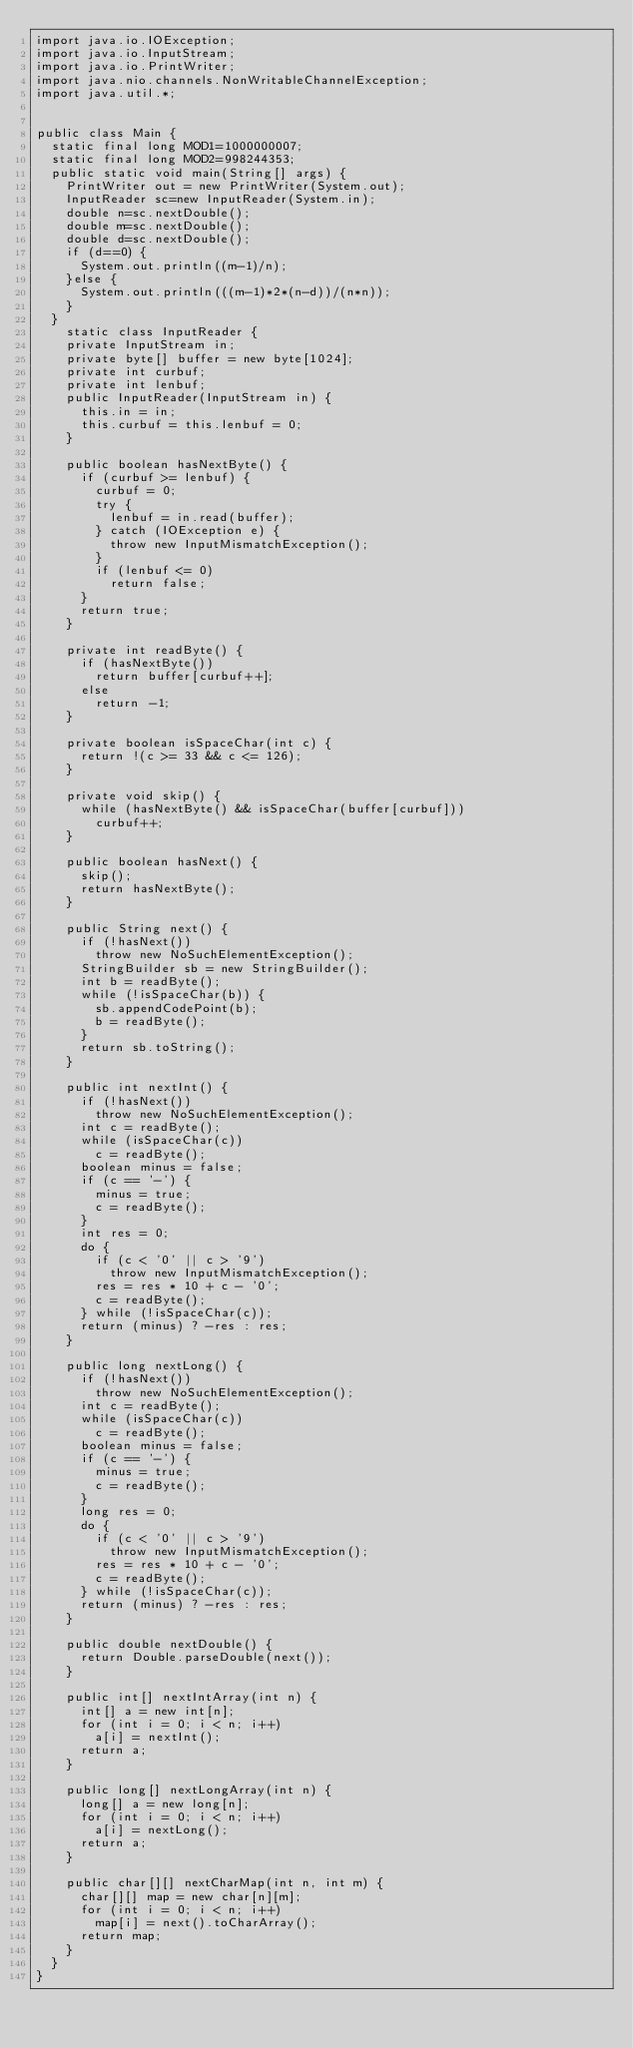Convert code to text. <code><loc_0><loc_0><loc_500><loc_500><_Java_>import java.io.IOException;
import java.io.InputStream;
import java.io.PrintWriter;
import java.nio.channels.NonWritableChannelException;
import java.util.*;

 
public class Main {
	static final long MOD1=1000000007;
	static final long MOD2=998244353;
	public static void main(String[] args) {
		PrintWriter out = new PrintWriter(System.out);
		InputReader sc=new InputReader(System.in);
		double n=sc.nextDouble();
		double m=sc.nextDouble();
		double d=sc.nextDouble();
		if (d==0) {
			System.out.println((m-1)/n);
		}else {
			System.out.println(((m-1)*2*(n-d))/(n*n));
		}
	}
		static class InputReader { 
		private InputStream in;
		private byte[] buffer = new byte[1024];
		private int curbuf;
		private int lenbuf;
		public InputReader(InputStream in) {
			this.in = in;
			this.curbuf = this.lenbuf = 0;
		}
 
		public boolean hasNextByte() {
			if (curbuf >= lenbuf) {
				curbuf = 0;
				try {
					lenbuf = in.read(buffer);
				} catch (IOException e) {
					throw new InputMismatchException();
				}
				if (lenbuf <= 0)
					return false;
			}
			return true;
		}
 
		private int readByte() {
			if (hasNextByte())
				return buffer[curbuf++];
			else
				return -1;
		}
 
		private boolean isSpaceChar(int c) {
			return !(c >= 33 && c <= 126);
		}
 
		private void skip() {
			while (hasNextByte() && isSpaceChar(buffer[curbuf]))
				curbuf++;
		}
 
		public boolean hasNext() {
			skip();
			return hasNextByte();
		}
 
		public String next() {
			if (!hasNext())
				throw new NoSuchElementException();
			StringBuilder sb = new StringBuilder();
			int b = readByte();
			while (!isSpaceChar(b)) {
				sb.appendCodePoint(b);
				b = readByte();
			}
			return sb.toString();
		}
 
		public int nextInt() {
			if (!hasNext())
				throw new NoSuchElementException();
			int c = readByte();
			while (isSpaceChar(c))
				c = readByte();
			boolean minus = false;
			if (c == '-') {
				minus = true;
				c = readByte();
			}
			int res = 0;
			do {
				if (c < '0' || c > '9')
					throw new InputMismatchException();
				res = res * 10 + c - '0';
				c = readByte();
			} while (!isSpaceChar(c));
			return (minus) ? -res : res;
		}
 
		public long nextLong() {
			if (!hasNext())
				throw new NoSuchElementException();
			int c = readByte();
			while (isSpaceChar(c))
				c = readByte();
			boolean minus = false;
			if (c == '-') {
				minus = true;
				c = readByte();
			}
			long res = 0;
			do {
				if (c < '0' || c > '9')
					throw new InputMismatchException();
				res = res * 10 + c - '0';
				c = readByte();
			} while (!isSpaceChar(c));
			return (minus) ? -res : res;
		}
 
		public double nextDouble() {
			return Double.parseDouble(next());
		}
 
		public int[] nextIntArray(int n) {
			int[] a = new int[n];
			for (int i = 0; i < n; i++)
				a[i] = nextInt();
			return a;
		}
 
		public long[] nextLongArray(int n) {
			long[] a = new long[n];
			for (int i = 0; i < n; i++)
				a[i] = nextLong();
			return a;
		}
 
		public char[][] nextCharMap(int n, int m) {
			char[][] map = new char[n][m];
			for (int i = 0; i < n; i++)
				map[i] = next().toCharArray();
			return map;
		}
	}
}
</code> 